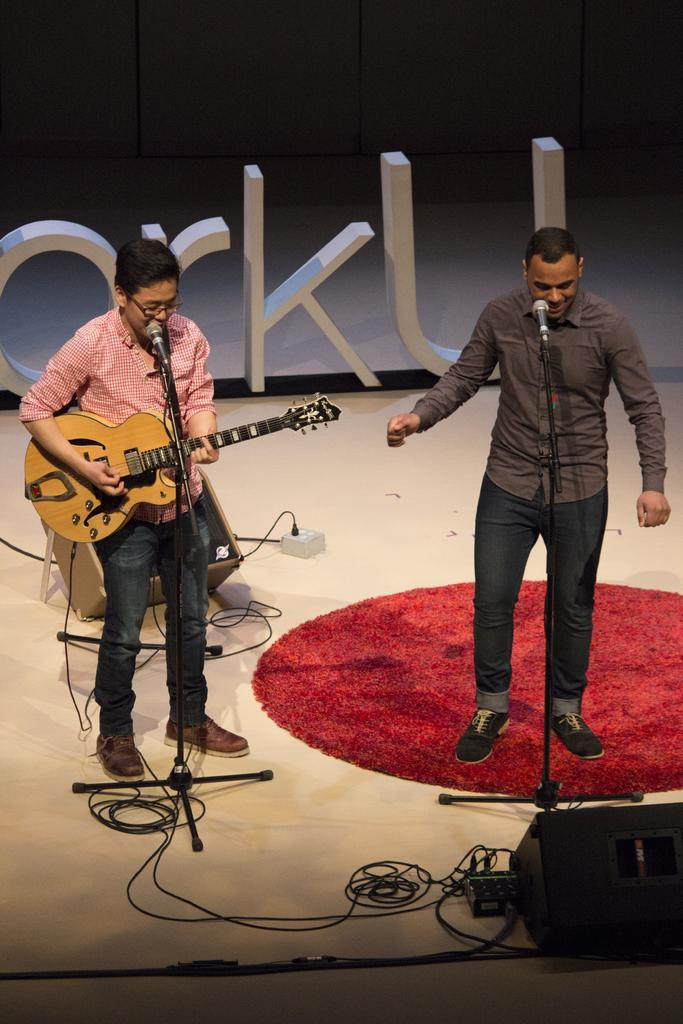How many people are in the image? There are two persons in the image. What are the two persons doing in the image? The two persons are singing, and one of them is playing a guitar. What object is used for amplifying their voices in the image? There is a microphone (mike) in the image. What type of surface is visible in the image? The image shows a floor. Can you see a cow playing with itself in the image? No, there is no cow present in the image, and the people are singing and playing a guitar, not playing with themselves. 